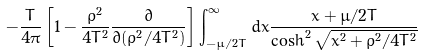Convert formula to latex. <formula><loc_0><loc_0><loc_500><loc_500>- \frac { T } { 4 \pi } \left [ 1 - \frac { \rho ^ { 2 } } { 4 T ^ { 2 } } \frac { \partial } { \partial ( \rho ^ { 2 } / 4 T ^ { 2 } ) } \right ] \int _ { - \mu / 2 T } ^ { \infty } d x \frac { x + \mu / 2 T } { \cosh ^ { 2 } \sqrt { x ^ { 2 } + \rho ^ { 2 } / 4 T ^ { 2 } } }</formula> 